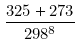<formula> <loc_0><loc_0><loc_500><loc_500>\frac { 3 2 5 + 2 7 3 } { 2 9 8 ^ { 8 } }</formula> 